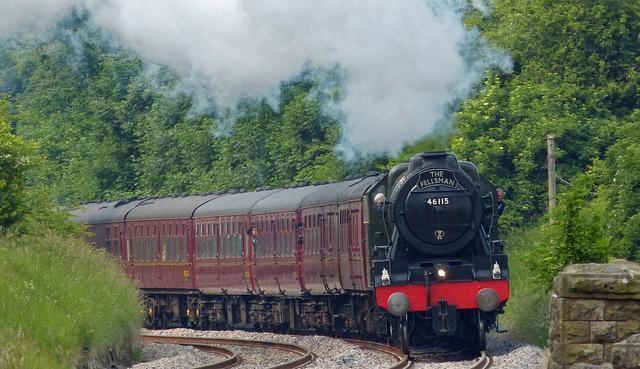How many train tracks are there?
Give a very brief answer. 2. 